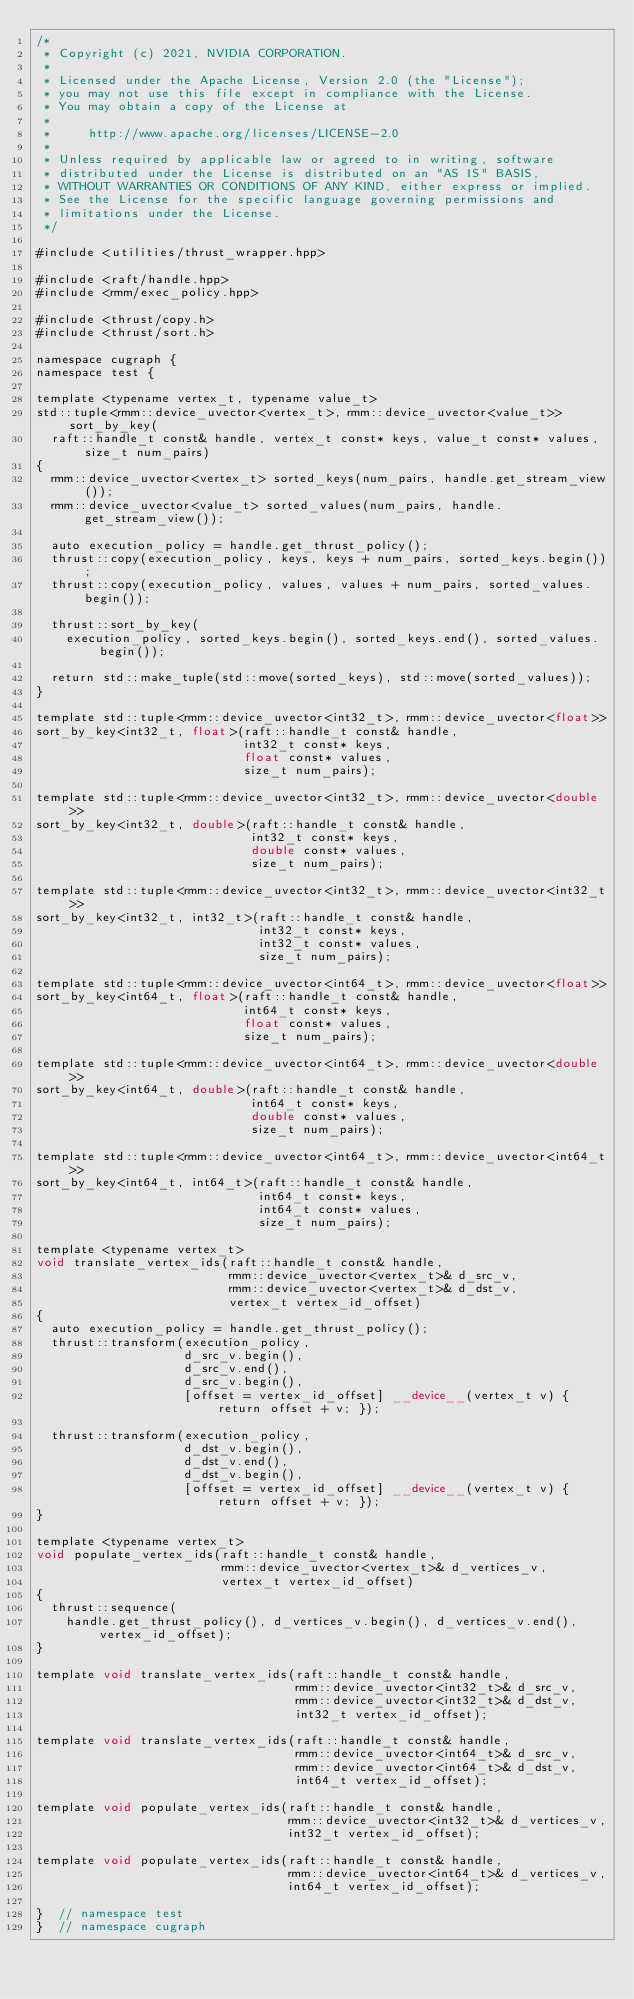<code> <loc_0><loc_0><loc_500><loc_500><_Cuda_>/*
 * Copyright (c) 2021, NVIDIA CORPORATION.
 *
 * Licensed under the Apache License, Version 2.0 (the "License");
 * you may not use this file except in compliance with the License.
 * You may obtain a copy of the License at
 *
 *     http://www.apache.org/licenses/LICENSE-2.0
 *
 * Unless required by applicable law or agreed to in writing, software
 * distributed under the License is distributed on an "AS IS" BASIS,
 * WITHOUT WARRANTIES OR CONDITIONS OF ANY KIND, either express or implied.
 * See the License for the specific language governing permissions and
 * limitations under the License.
 */

#include <utilities/thrust_wrapper.hpp>

#include <raft/handle.hpp>
#include <rmm/exec_policy.hpp>

#include <thrust/copy.h>
#include <thrust/sort.h>

namespace cugraph {
namespace test {

template <typename vertex_t, typename value_t>
std::tuple<rmm::device_uvector<vertex_t>, rmm::device_uvector<value_t>> sort_by_key(
  raft::handle_t const& handle, vertex_t const* keys, value_t const* values, size_t num_pairs)
{
  rmm::device_uvector<vertex_t> sorted_keys(num_pairs, handle.get_stream_view());
  rmm::device_uvector<value_t> sorted_values(num_pairs, handle.get_stream_view());

  auto execution_policy = handle.get_thrust_policy();
  thrust::copy(execution_policy, keys, keys + num_pairs, sorted_keys.begin());
  thrust::copy(execution_policy, values, values + num_pairs, sorted_values.begin());

  thrust::sort_by_key(
    execution_policy, sorted_keys.begin(), sorted_keys.end(), sorted_values.begin());

  return std::make_tuple(std::move(sorted_keys), std::move(sorted_values));
}

template std::tuple<rmm::device_uvector<int32_t>, rmm::device_uvector<float>>
sort_by_key<int32_t, float>(raft::handle_t const& handle,
                            int32_t const* keys,
                            float const* values,
                            size_t num_pairs);

template std::tuple<rmm::device_uvector<int32_t>, rmm::device_uvector<double>>
sort_by_key<int32_t, double>(raft::handle_t const& handle,
                             int32_t const* keys,
                             double const* values,
                             size_t num_pairs);

template std::tuple<rmm::device_uvector<int32_t>, rmm::device_uvector<int32_t>>
sort_by_key<int32_t, int32_t>(raft::handle_t const& handle,
                              int32_t const* keys,
                              int32_t const* values,
                              size_t num_pairs);

template std::tuple<rmm::device_uvector<int64_t>, rmm::device_uvector<float>>
sort_by_key<int64_t, float>(raft::handle_t const& handle,
                            int64_t const* keys,
                            float const* values,
                            size_t num_pairs);

template std::tuple<rmm::device_uvector<int64_t>, rmm::device_uvector<double>>
sort_by_key<int64_t, double>(raft::handle_t const& handle,
                             int64_t const* keys,
                             double const* values,
                             size_t num_pairs);

template std::tuple<rmm::device_uvector<int64_t>, rmm::device_uvector<int64_t>>
sort_by_key<int64_t, int64_t>(raft::handle_t const& handle,
                              int64_t const* keys,
                              int64_t const* values,
                              size_t num_pairs);

template <typename vertex_t>
void translate_vertex_ids(raft::handle_t const& handle,
                          rmm::device_uvector<vertex_t>& d_src_v,
                          rmm::device_uvector<vertex_t>& d_dst_v,
                          vertex_t vertex_id_offset)
{
  auto execution_policy = handle.get_thrust_policy();
  thrust::transform(execution_policy,
                    d_src_v.begin(),
                    d_src_v.end(),
                    d_src_v.begin(),
                    [offset = vertex_id_offset] __device__(vertex_t v) { return offset + v; });

  thrust::transform(execution_policy,
                    d_dst_v.begin(),
                    d_dst_v.end(),
                    d_dst_v.begin(),
                    [offset = vertex_id_offset] __device__(vertex_t v) { return offset + v; });
}

template <typename vertex_t>
void populate_vertex_ids(raft::handle_t const& handle,
                         rmm::device_uvector<vertex_t>& d_vertices_v,
                         vertex_t vertex_id_offset)
{
  thrust::sequence(
    handle.get_thrust_policy(), d_vertices_v.begin(), d_vertices_v.end(), vertex_id_offset);
}

template void translate_vertex_ids(raft::handle_t const& handle,
                                   rmm::device_uvector<int32_t>& d_src_v,
                                   rmm::device_uvector<int32_t>& d_dst_v,
                                   int32_t vertex_id_offset);

template void translate_vertex_ids(raft::handle_t const& handle,
                                   rmm::device_uvector<int64_t>& d_src_v,
                                   rmm::device_uvector<int64_t>& d_dst_v,
                                   int64_t vertex_id_offset);

template void populate_vertex_ids(raft::handle_t const& handle,
                                  rmm::device_uvector<int32_t>& d_vertices_v,
                                  int32_t vertex_id_offset);

template void populate_vertex_ids(raft::handle_t const& handle,
                                  rmm::device_uvector<int64_t>& d_vertices_v,
                                  int64_t vertex_id_offset);

}  // namespace test
}  // namespace cugraph
</code> 